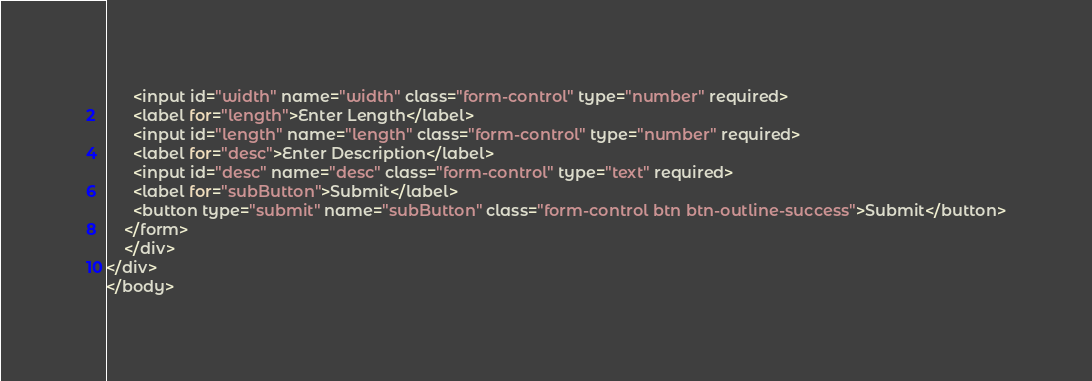<code> <loc_0><loc_0><loc_500><loc_500><_C#_>      <input id="width" name="width" class="form-control" type="number" required>
      <label for="length">Enter Length</label>
      <input id="length" name="length" class="form-control" type="number" required>
      <label for="desc">Enter Description</label>
      <input id="desc" name="desc" class="form-control" type="text" required>
      <label for="subButton">Submit</label>
      <button type="submit" name="subButton" class="form-control btn btn-outline-success">Submit</button>
    </form>
    </div>
</div>
</body></code> 